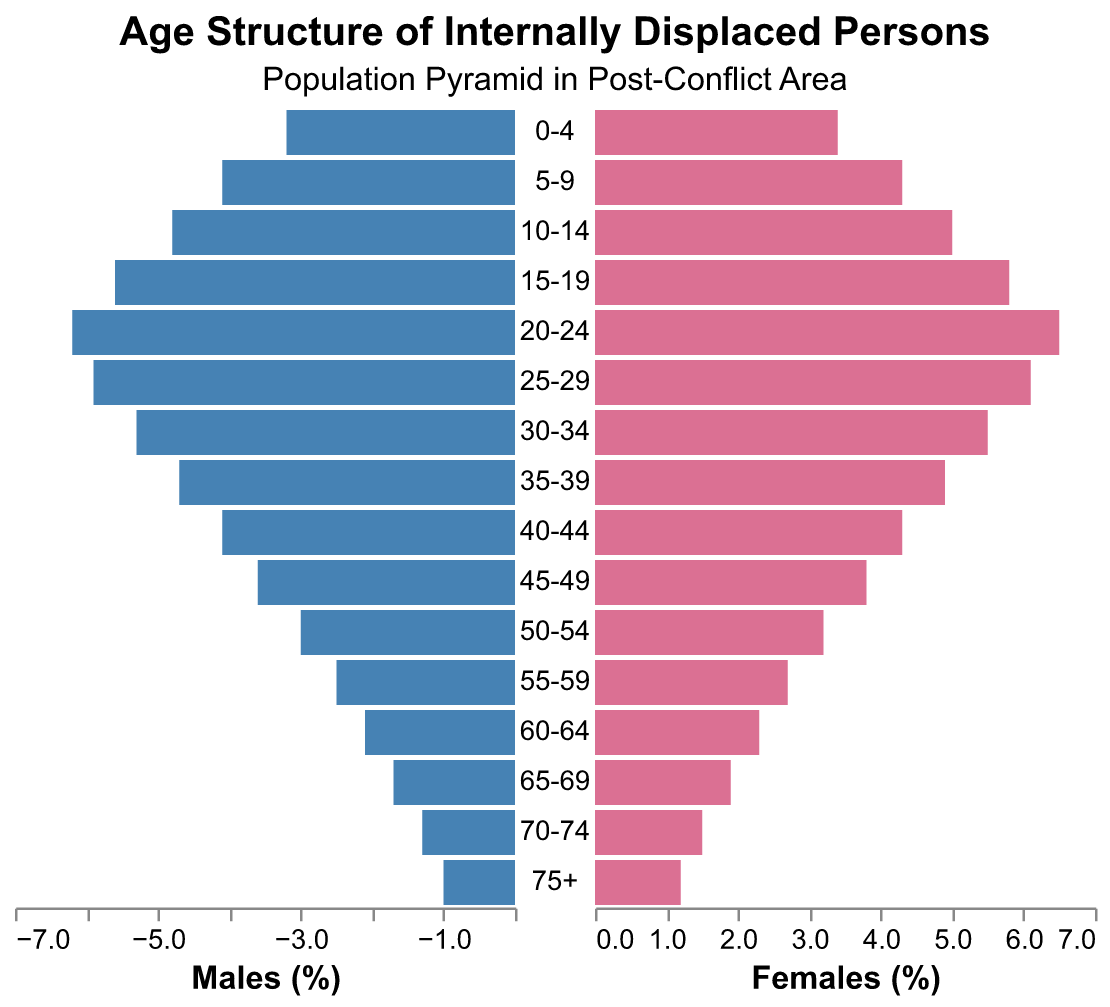What's the title of the figure? The title is located at the top of the figure and provides an overview of what the chart represents. The main title is "Age Structure of Internally Displaced Persons" and the subtitle is "Population Pyramid in Post-Conflict Area".
Answer: Age Structure of Internally Displaced Persons What percentage of the population are females aged 20-24? To find this, locate the bar corresponding to the age group 20-24 on the right side (females). The tooltip or bar value indicates that it is 6.5%.
Answer: 6.5% How does the population percentage of males aged 15-19 compare to that of females in the same age group? Compare the bars for the 15-19 age group on both sides. Males have 5.6% while females have 5.8%. Therefore, females have a higher percentage.
Answer: Females have a higher percentage Which age group has the smallest percentage of males? Identify the shortest bar on the left side, representing males. The age group 75+ has the smallest percentage, with 1.0%.
Answer: 75+ Which gender has a higher population percentage in the age group 30-34? Compare the bars for the 30-34 age group on both sides. Males have 5.3%, whereas females have 5.5%. Therefore, females have a higher percentage in this age group.
Answer: Females What is the total percentage of the population aged 0-9 for males? Sum the percentages for the age groups 0-4 and 5-9 on the left side (males): 3.2% + 4.1% = 7.3%.
Answer: 7.3% Which age group shows equal population percentages for both males and females? Compare the bars for each age group. The age group 0-4 has males at 3.2% and females at 3.4%, which are close but not equal. Continue comparing each group similarly. No group has exactly equal percentages, but the 0-4 group is the closest.
Answer: None, but 0-4 is closest What is the average percentage of the population for females aged 50-74? Identify the bars for age groups 50-54, 55-59, 60-64, 65-69, and 70-74 on the right side. Average these values: (3.2 + 2.7 + 2.3 + 1.9 + 1.5) / 5 = 2.32%.
Answer: 2.32% What is the percentage difference between males and females in the age group 20-24? Subtract the percentage of males from that of females in the age group 20-24: 6.5% - 6.2% = 0.3%.
Answer: 0.3% 